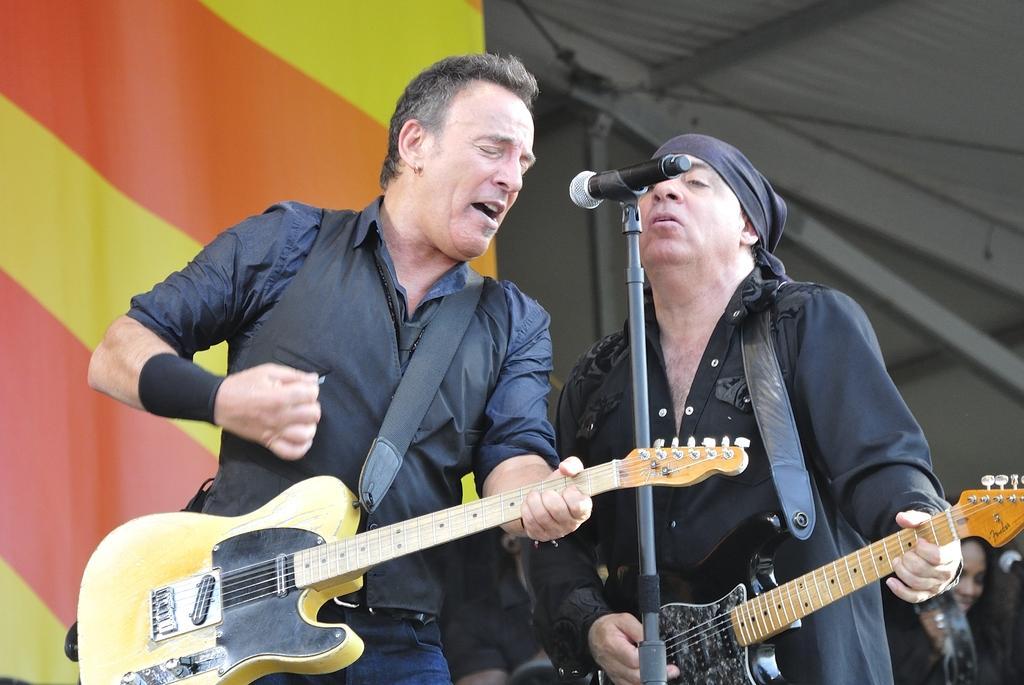In one or two sentences, can you explain what this image depicts? In this image i can see two men holding a guitar and singing,there is a micro phone in front of the man beside the man there is a woman. At the background i can see a banner at the top of the image there is a shed. 